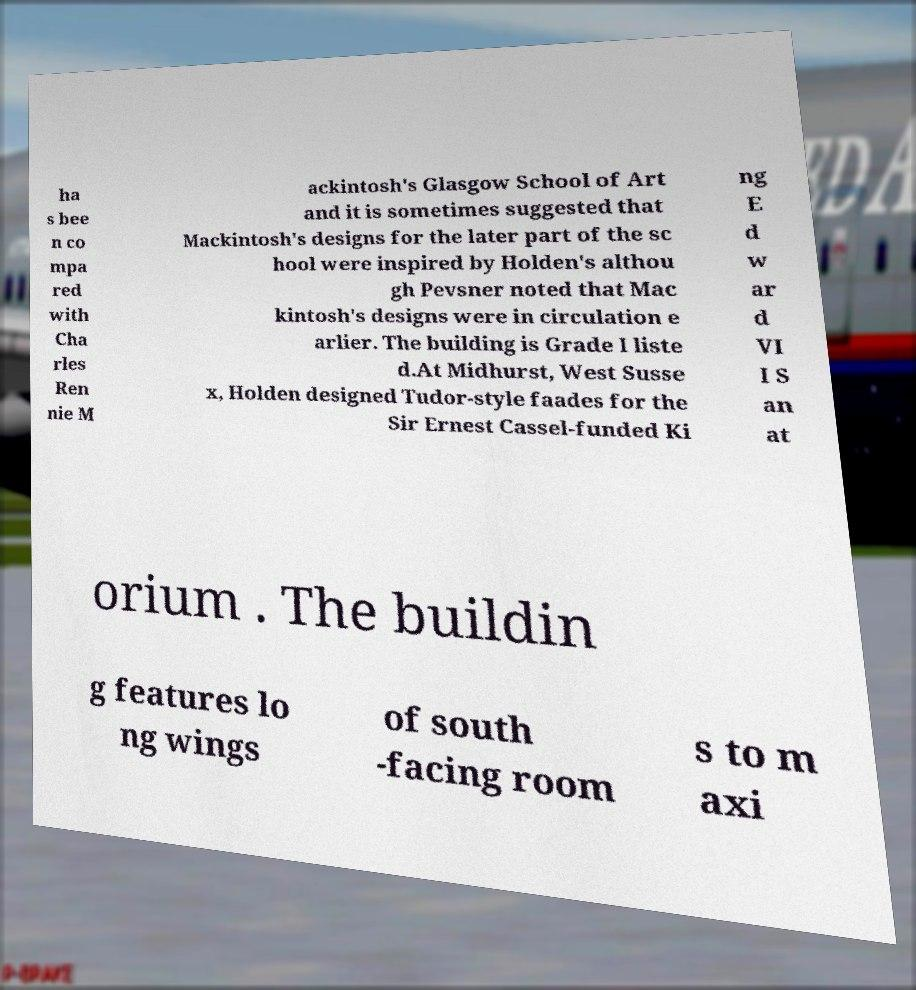Can you accurately transcribe the text from the provided image for me? ha s bee n co mpa red with Cha rles Ren nie M ackintosh's Glasgow School of Art and it is sometimes suggested that Mackintosh's designs for the later part of the sc hool were inspired by Holden's althou gh Pevsner noted that Mac kintosh's designs were in circulation e arlier. The building is Grade I liste d.At Midhurst, West Susse x, Holden designed Tudor-style faades for the Sir Ernest Cassel-funded Ki ng E d w ar d VI I S an at orium . The buildin g features lo ng wings of south -facing room s to m axi 